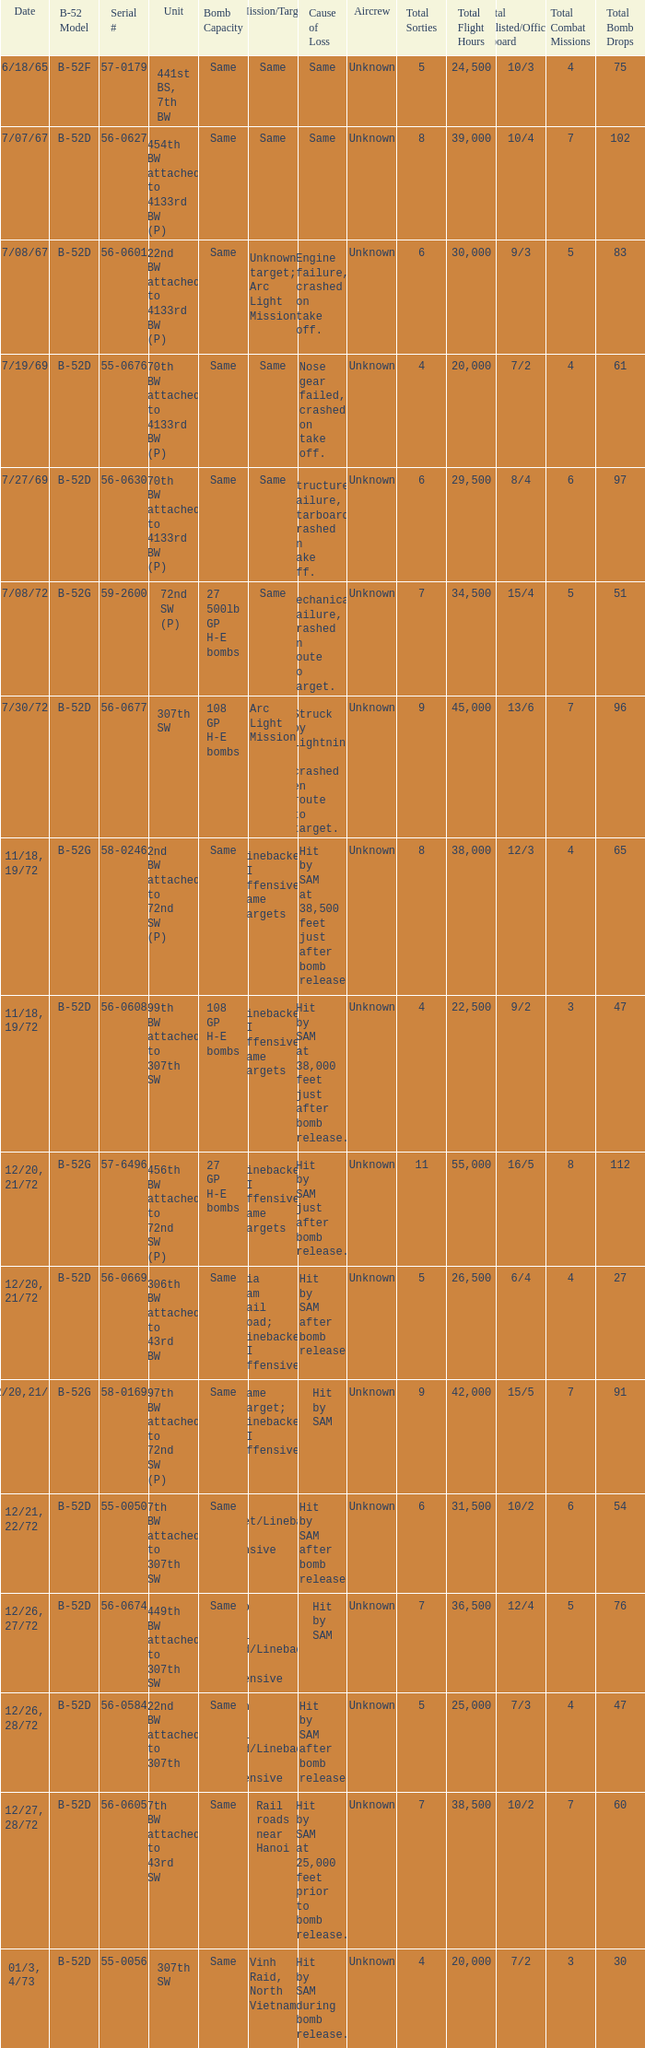When 7th bw attached to 43rd sw is the unit what is the b-52 model? B-52D. 